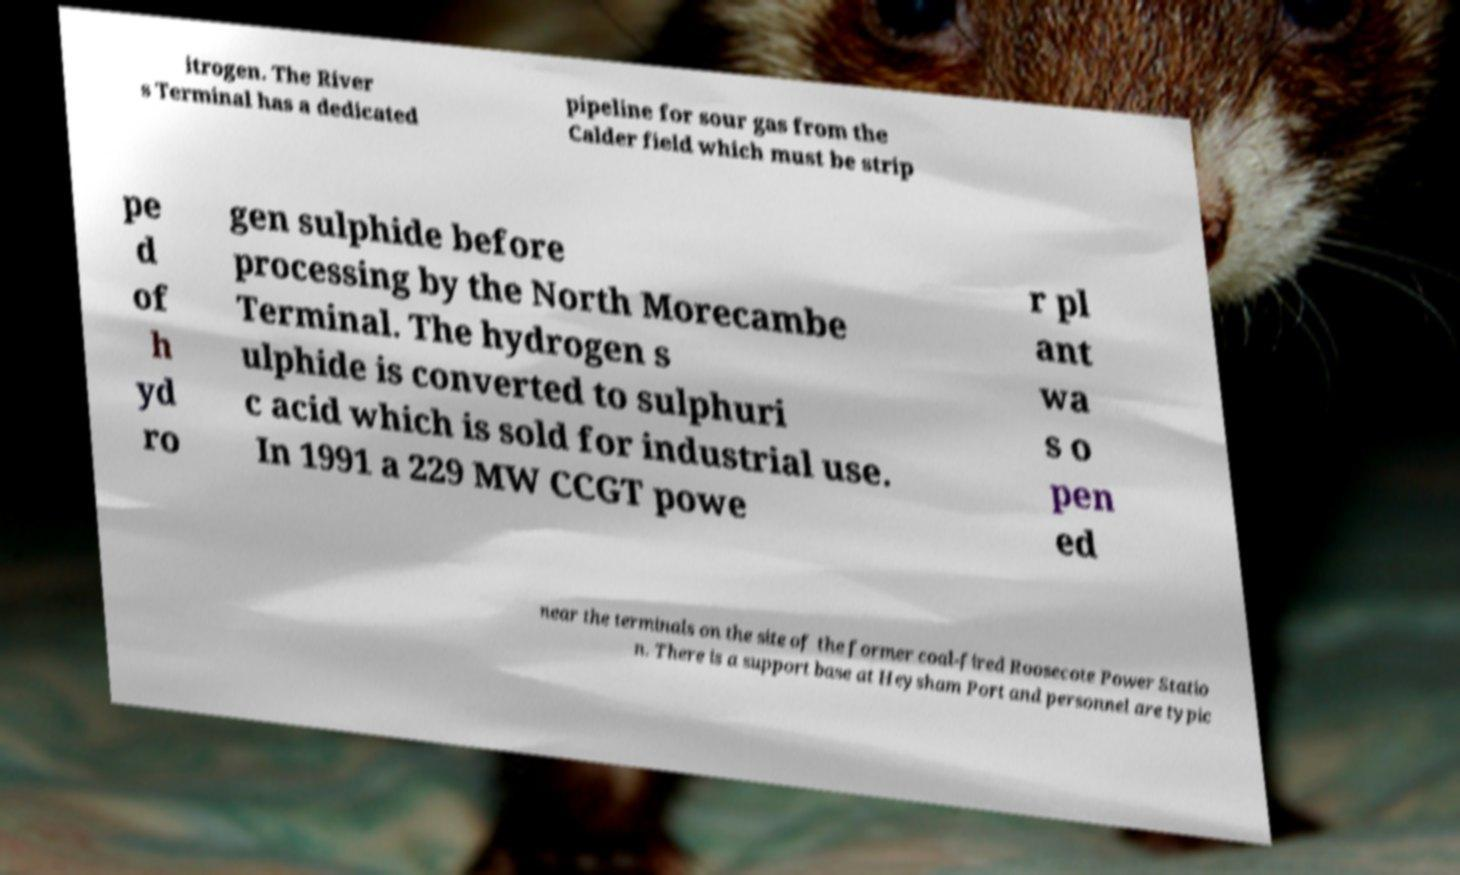What messages or text are displayed in this image? I need them in a readable, typed format. itrogen. The River s Terminal has a dedicated pipeline for sour gas from the Calder field which must be strip pe d of h yd ro gen sulphide before processing by the North Morecambe Terminal. The hydrogen s ulphide is converted to sulphuri c acid which is sold for industrial use. In 1991 a 229 MW CCGT powe r pl ant wa s o pen ed near the terminals on the site of the former coal-fired Roosecote Power Statio n. There is a support base at Heysham Port and personnel are typic 